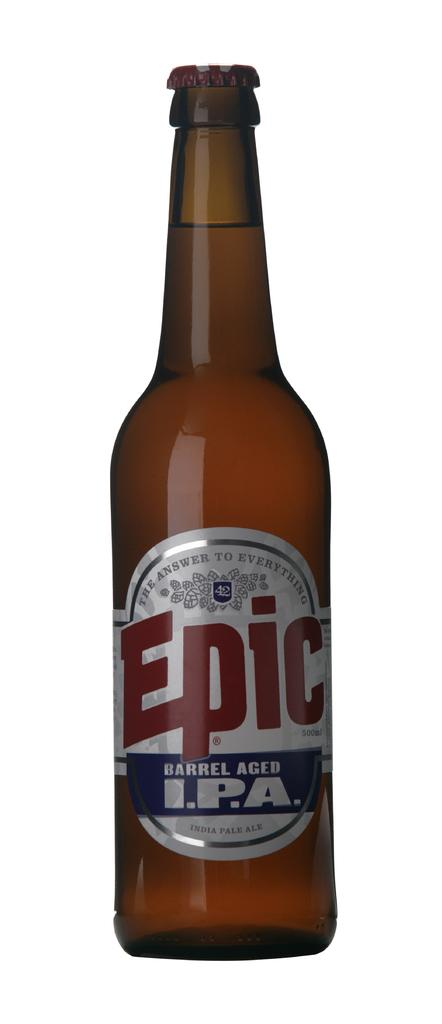Provide a one-sentence caption for the provided image. A beer bottle with a label on it named Epic. 